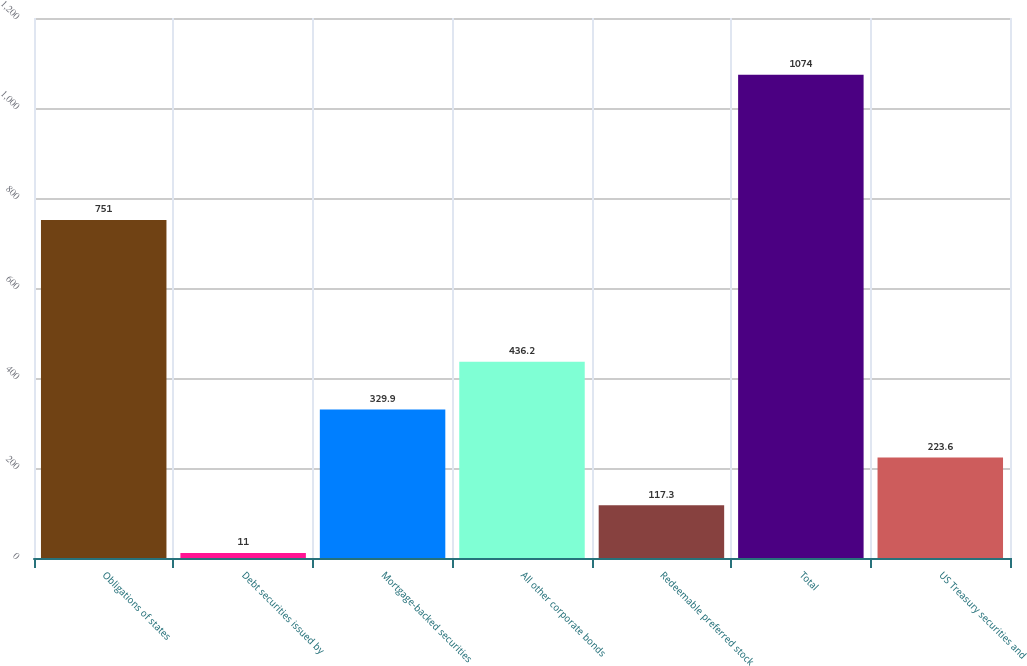Convert chart to OTSL. <chart><loc_0><loc_0><loc_500><loc_500><bar_chart><fcel>Obligations of states<fcel>Debt securities issued by<fcel>Mortgage-backed securities<fcel>All other corporate bonds<fcel>Redeemable preferred stock<fcel>Total<fcel>US Treasury securities and<nl><fcel>751<fcel>11<fcel>329.9<fcel>436.2<fcel>117.3<fcel>1074<fcel>223.6<nl></chart> 